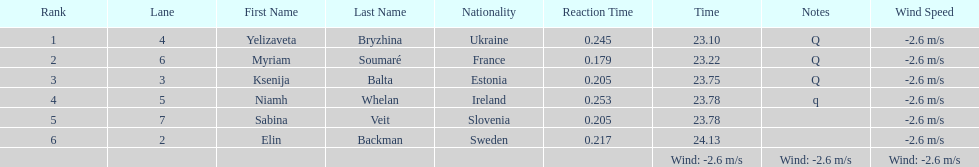How long did it take elin backman to finish the race? 24.13. 